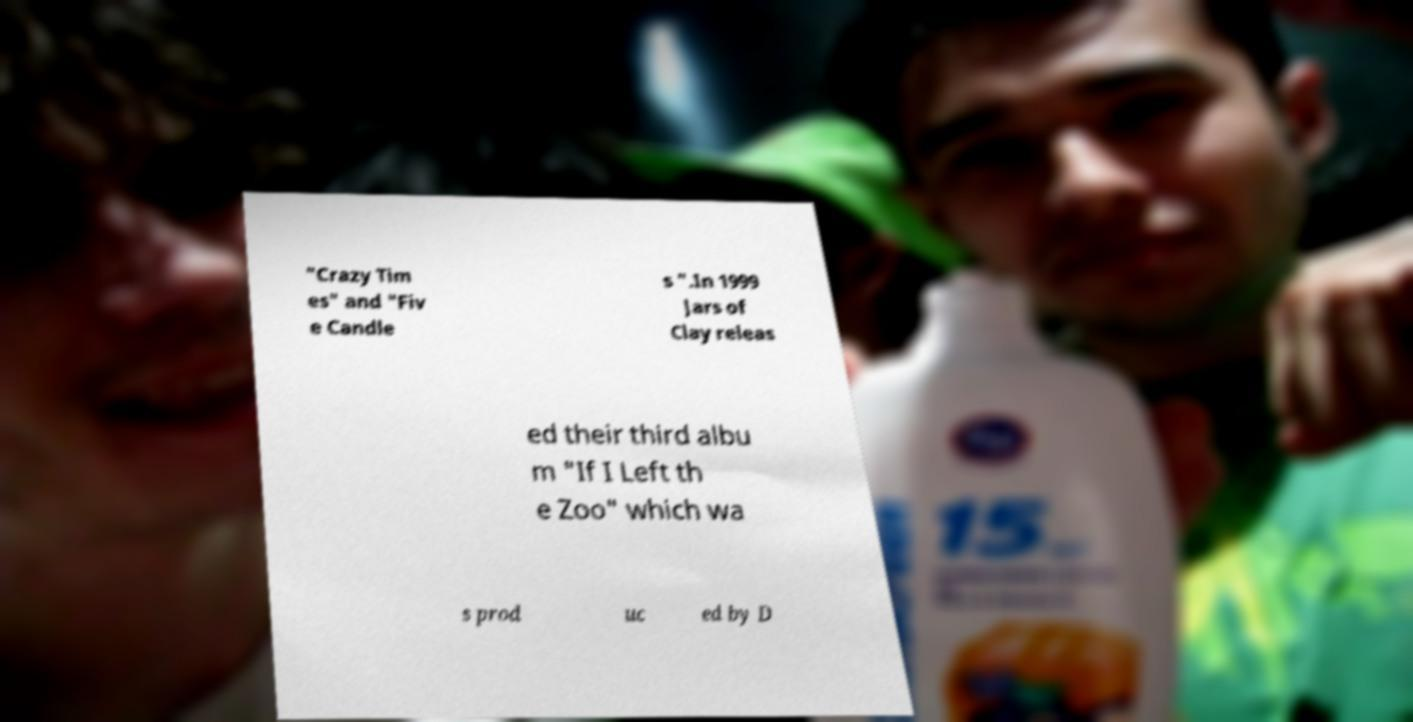Can you accurately transcribe the text from the provided image for me? "Crazy Tim es" and "Fiv e Candle s ".In 1999 Jars of Clay releas ed their third albu m "If I Left th e Zoo" which wa s prod uc ed by D 